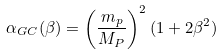<formula> <loc_0><loc_0><loc_500><loc_500>\alpha _ { G C } ( \beta ) = \left ( \frac { m _ { p } } { M _ { P } } \right ) ^ { 2 } ( 1 + 2 \beta ^ { 2 } )</formula> 